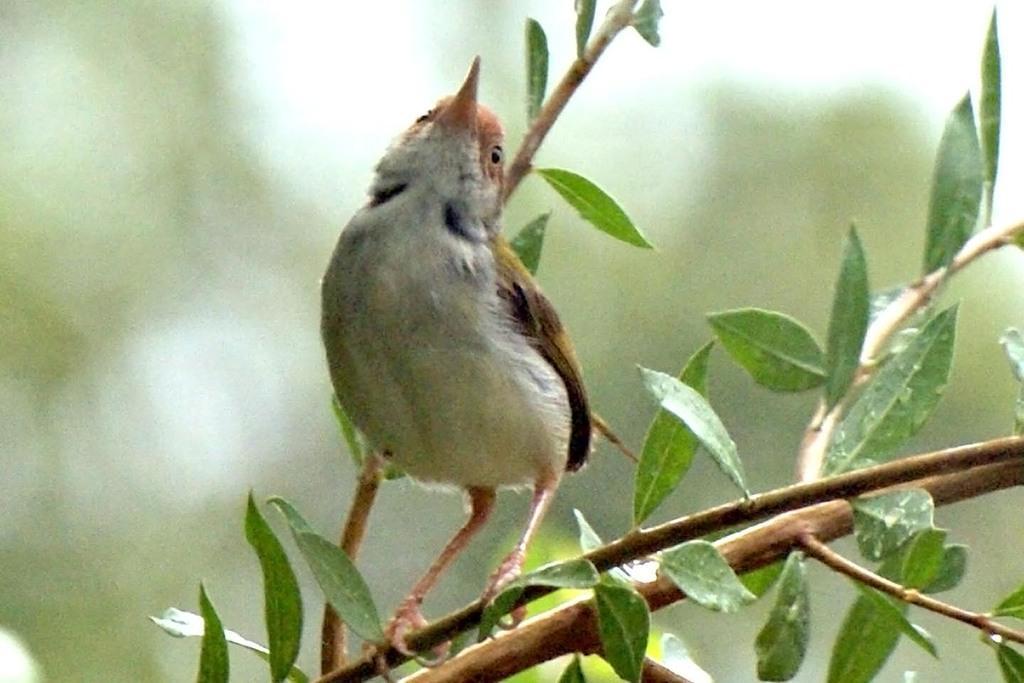Please provide a concise description of this image. In this image there is a bird standing on a stem. There are leaves to the stem. The background is blurry. 